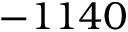Convert formula to latex. <formula><loc_0><loc_0><loc_500><loc_500>- 1 1 4 0</formula> 